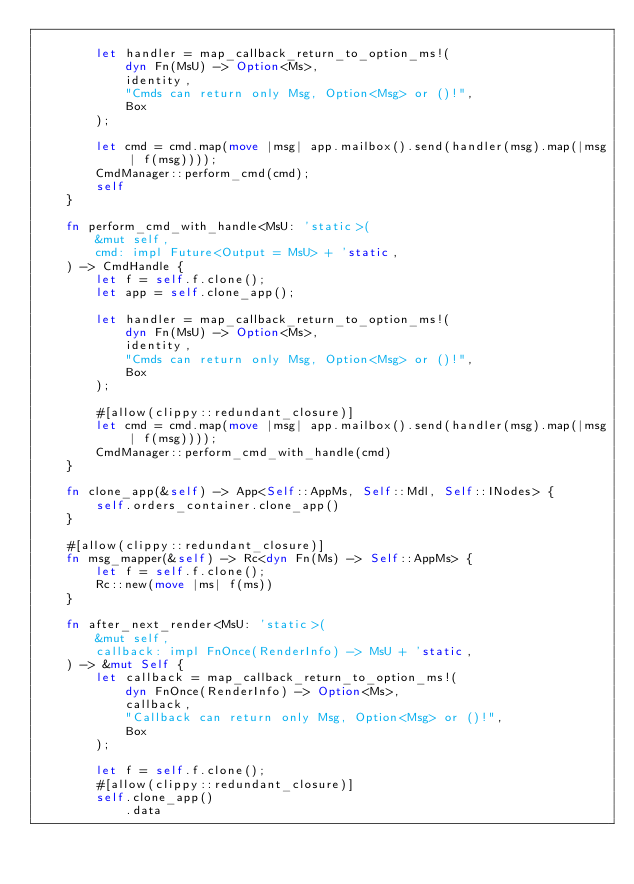<code> <loc_0><loc_0><loc_500><loc_500><_Rust_>
        let handler = map_callback_return_to_option_ms!(
            dyn Fn(MsU) -> Option<Ms>,
            identity,
            "Cmds can return only Msg, Option<Msg> or ()!",
            Box
        );

        let cmd = cmd.map(move |msg| app.mailbox().send(handler(msg).map(|msg| f(msg))));
        CmdManager::perform_cmd(cmd);
        self
    }

    fn perform_cmd_with_handle<MsU: 'static>(
        &mut self,
        cmd: impl Future<Output = MsU> + 'static,
    ) -> CmdHandle {
        let f = self.f.clone();
        let app = self.clone_app();

        let handler = map_callback_return_to_option_ms!(
            dyn Fn(MsU) -> Option<Ms>,
            identity,
            "Cmds can return only Msg, Option<Msg> or ()!",
            Box
        );

        #[allow(clippy::redundant_closure)]
        let cmd = cmd.map(move |msg| app.mailbox().send(handler(msg).map(|msg| f(msg))));
        CmdManager::perform_cmd_with_handle(cmd)
    }

    fn clone_app(&self) -> App<Self::AppMs, Self::Mdl, Self::INodes> {
        self.orders_container.clone_app()
    }

    #[allow(clippy::redundant_closure)]
    fn msg_mapper(&self) -> Rc<dyn Fn(Ms) -> Self::AppMs> {
        let f = self.f.clone();
        Rc::new(move |ms| f(ms))
    }

    fn after_next_render<MsU: 'static>(
        &mut self,
        callback: impl FnOnce(RenderInfo) -> MsU + 'static,
    ) -> &mut Self {
        let callback = map_callback_return_to_option_ms!(
            dyn FnOnce(RenderInfo) -> Option<Ms>,
            callback,
            "Callback can return only Msg, Option<Msg> or ()!",
            Box
        );

        let f = self.f.clone();
        #[allow(clippy::redundant_closure)]
        self.clone_app()
            .data</code> 